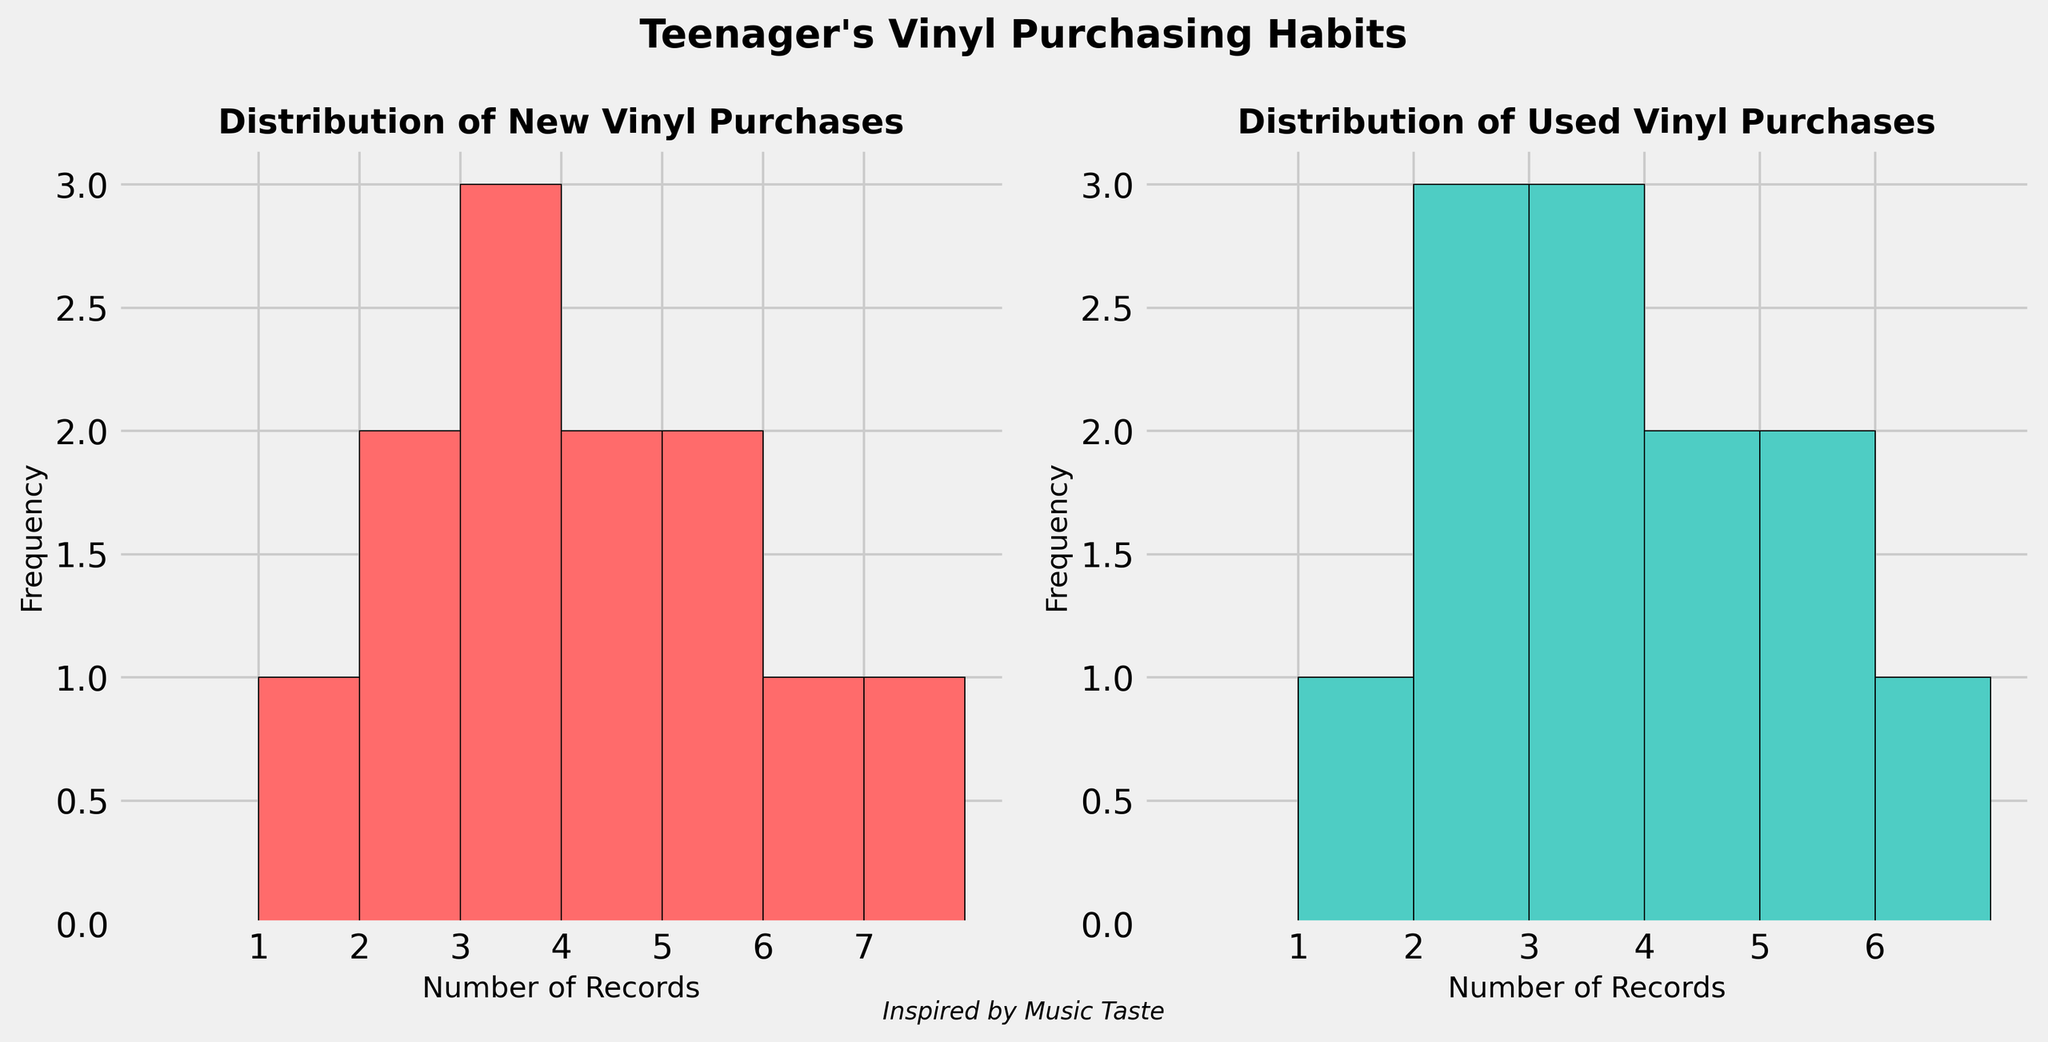What are the titles of the two histograms in the figure? The titles are the heading text on top of each subplot. In this case, the first histogram is titled "Distribution of New Vinyl Purchases" and the second histogram is titled "Distribution of Used Vinyl Purchases".
Answer: "Distribution of New Vinyl Purchases" and "Distribution of Used Vinyl Purchases" What is the range of records purchased in the "Distribution of New Vinyl Purchases" histogram? The x-axis shows the number of records, ranging from 0 to 8. However, the bins with visible data range from 1 to 7 records. The y-axis indicates the frequency for these bins.
Answer: 1 to 7 records Which month had the highest number of new vinyl records purchased, and how many were purchased? From the histogram for new records, December is the month with the highest bar, indicating the highest number of new vinyl records purchased. Counting from the x-axis, December had 7 new records.
Answer: December, 7 records Which month had the highest number of used vinyl records purchased, and how many were purchased? Observe the histogram for used records. September’s bar is the highest, indicating it had the most used vinyl purchases. The x-axis shows these purchases are 6 records.
Answer: September, 6 records What is the most common number of new vinyl records purchased in a month? The histogram for new records shows the most frequent height on the y-axis. The most common bar height corresponds to 3 records purchased in a month.
Answer: 3 records Compare the frequencies of purchasing 5 new records vs. 5 used records in a month. The histogram for new records shows that buying 5 new records happened twice (two bars of height 1). For used records, the purchase of 5 records happened three times (three bars of height 1).
Answer: 2 times (new), 3 times (used) What is the specified x-tick interval for both histograms? The x-tick intervals are specified as set labels on the x-axes of both histograms. The new records have ticks from 1 to 7, and the used records have ticks from 1 to 6.
Answer: 1 to 7 (new), 1 to 6 (used) Calculate the mean number of new records purchased each month. Sum the number of new records for each month (2+1+3+2+4+5+3+6+4+5+3+7=45) and divide by the number of months (12).
Answer: 3.75 records Identify any month(s) where the number of new and used records purchased are equal, and specify the number of records. Compare the number of new and used records month by month: March (3 new and 2 used), May (4 new and 3 used), and October (5 new and 3 used) are not equal. No months have equal purchases.
Answer: No months How many months had more used records purchased than new records purchased? Compare the number of used records to new records month by month: February, April, July, September, and November. These months had more used than new records purchased.
Answer: 5 months 